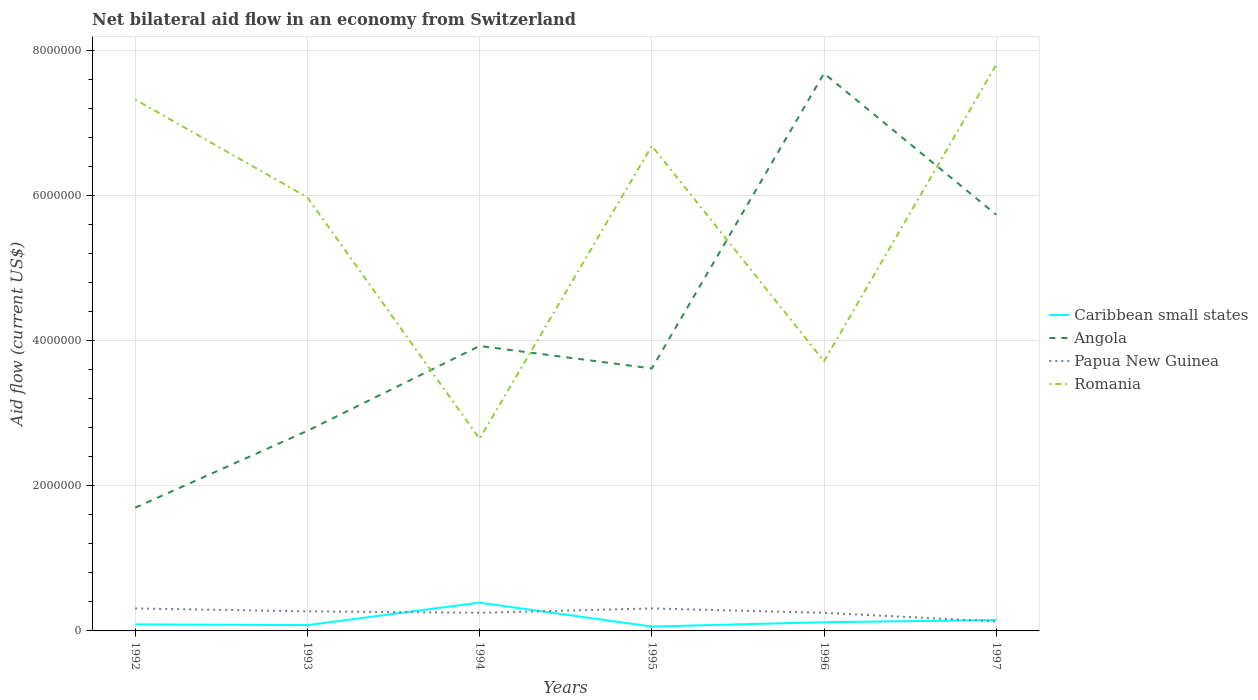How many different coloured lines are there?
Provide a succinct answer. 4. Does the line corresponding to Romania intersect with the line corresponding to Angola?
Offer a very short reply. Yes. Is the number of lines equal to the number of legend labels?
Your response must be concise. Yes. Across all years, what is the maximum net bilateral aid flow in Romania?
Your response must be concise. 2.65e+06. In which year was the net bilateral aid flow in Papua New Guinea maximum?
Offer a terse response. 1997. What is the difference between the highest and the second highest net bilateral aid flow in Romania?
Keep it short and to the point. 5.16e+06. What is the difference between the highest and the lowest net bilateral aid flow in Caribbean small states?
Offer a terse response. 2. Is the net bilateral aid flow in Caribbean small states strictly greater than the net bilateral aid flow in Papua New Guinea over the years?
Give a very brief answer. No. What is the difference between two consecutive major ticks on the Y-axis?
Provide a succinct answer. 2.00e+06. Are the values on the major ticks of Y-axis written in scientific E-notation?
Keep it short and to the point. No. Where does the legend appear in the graph?
Provide a succinct answer. Center right. How many legend labels are there?
Keep it short and to the point. 4. How are the legend labels stacked?
Make the answer very short. Vertical. What is the title of the graph?
Ensure brevity in your answer.  Net bilateral aid flow in an economy from Switzerland. What is the label or title of the Y-axis?
Give a very brief answer. Aid flow (current US$). What is the Aid flow (current US$) in Angola in 1992?
Your answer should be compact. 1.70e+06. What is the Aid flow (current US$) of Papua New Guinea in 1992?
Give a very brief answer. 3.10e+05. What is the Aid flow (current US$) of Romania in 1992?
Make the answer very short. 7.33e+06. What is the Aid flow (current US$) of Caribbean small states in 1993?
Keep it short and to the point. 8.00e+04. What is the Aid flow (current US$) in Angola in 1993?
Offer a terse response. 2.76e+06. What is the Aid flow (current US$) of Papua New Guinea in 1993?
Give a very brief answer. 2.70e+05. What is the Aid flow (current US$) of Romania in 1993?
Give a very brief answer. 5.98e+06. What is the Aid flow (current US$) in Caribbean small states in 1994?
Offer a very short reply. 3.90e+05. What is the Aid flow (current US$) of Angola in 1994?
Your response must be concise. 3.93e+06. What is the Aid flow (current US$) in Papua New Guinea in 1994?
Your answer should be very brief. 2.50e+05. What is the Aid flow (current US$) in Romania in 1994?
Provide a succinct answer. 2.65e+06. What is the Aid flow (current US$) of Caribbean small states in 1995?
Provide a short and direct response. 6.00e+04. What is the Aid flow (current US$) in Angola in 1995?
Provide a succinct answer. 3.62e+06. What is the Aid flow (current US$) in Romania in 1995?
Your answer should be very brief. 6.69e+06. What is the Aid flow (current US$) of Angola in 1996?
Offer a very short reply. 7.69e+06. What is the Aid flow (current US$) in Papua New Guinea in 1996?
Provide a short and direct response. 2.50e+05. What is the Aid flow (current US$) in Romania in 1996?
Provide a short and direct response. 3.72e+06. What is the Aid flow (current US$) in Angola in 1997?
Your answer should be compact. 5.74e+06. What is the Aid flow (current US$) in Romania in 1997?
Give a very brief answer. 7.81e+06. Across all years, what is the maximum Aid flow (current US$) in Caribbean small states?
Make the answer very short. 3.90e+05. Across all years, what is the maximum Aid flow (current US$) in Angola?
Your response must be concise. 7.69e+06. Across all years, what is the maximum Aid flow (current US$) in Romania?
Offer a terse response. 7.81e+06. Across all years, what is the minimum Aid flow (current US$) in Angola?
Offer a terse response. 1.70e+06. Across all years, what is the minimum Aid flow (current US$) of Papua New Guinea?
Your answer should be very brief. 1.30e+05. Across all years, what is the minimum Aid flow (current US$) in Romania?
Your answer should be very brief. 2.65e+06. What is the total Aid flow (current US$) in Caribbean small states in the graph?
Keep it short and to the point. 8.90e+05. What is the total Aid flow (current US$) of Angola in the graph?
Provide a short and direct response. 2.54e+07. What is the total Aid flow (current US$) of Papua New Guinea in the graph?
Keep it short and to the point. 1.52e+06. What is the total Aid flow (current US$) of Romania in the graph?
Your response must be concise. 3.42e+07. What is the difference between the Aid flow (current US$) in Angola in 1992 and that in 1993?
Provide a short and direct response. -1.06e+06. What is the difference between the Aid flow (current US$) of Papua New Guinea in 1992 and that in 1993?
Provide a succinct answer. 4.00e+04. What is the difference between the Aid flow (current US$) of Romania in 1992 and that in 1993?
Give a very brief answer. 1.35e+06. What is the difference between the Aid flow (current US$) in Caribbean small states in 1992 and that in 1994?
Ensure brevity in your answer.  -3.00e+05. What is the difference between the Aid flow (current US$) in Angola in 1992 and that in 1994?
Your answer should be very brief. -2.23e+06. What is the difference between the Aid flow (current US$) of Papua New Guinea in 1992 and that in 1994?
Provide a succinct answer. 6.00e+04. What is the difference between the Aid flow (current US$) in Romania in 1992 and that in 1994?
Ensure brevity in your answer.  4.68e+06. What is the difference between the Aid flow (current US$) in Angola in 1992 and that in 1995?
Offer a very short reply. -1.92e+06. What is the difference between the Aid flow (current US$) of Papua New Guinea in 1992 and that in 1995?
Keep it short and to the point. 0. What is the difference between the Aid flow (current US$) in Romania in 1992 and that in 1995?
Ensure brevity in your answer.  6.40e+05. What is the difference between the Aid flow (current US$) in Angola in 1992 and that in 1996?
Offer a terse response. -5.99e+06. What is the difference between the Aid flow (current US$) in Romania in 1992 and that in 1996?
Give a very brief answer. 3.61e+06. What is the difference between the Aid flow (current US$) of Caribbean small states in 1992 and that in 1997?
Ensure brevity in your answer.  -6.00e+04. What is the difference between the Aid flow (current US$) in Angola in 1992 and that in 1997?
Provide a short and direct response. -4.04e+06. What is the difference between the Aid flow (current US$) of Papua New Guinea in 1992 and that in 1997?
Offer a very short reply. 1.80e+05. What is the difference between the Aid flow (current US$) of Romania in 1992 and that in 1997?
Your response must be concise. -4.80e+05. What is the difference between the Aid flow (current US$) in Caribbean small states in 1993 and that in 1994?
Offer a very short reply. -3.10e+05. What is the difference between the Aid flow (current US$) of Angola in 1993 and that in 1994?
Make the answer very short. -1.17e+06. What is the difference between the Aid flow (current US$) of Papua New Guinea in 1993 and that in 1994?
Offer a terse response. 2.00e+04. What is the difference between the Aid flow (current US$) in Romania in 1993 and that in 1994?
Your answer should be compact. 3.33e+06. What is the difference between the Aid flow (current US$) of Caribbean small states in 1993 and that in 1995?
Ensure brevity in your answer.  2.00e+04. What is the difference between the Aid flow (current US$) of Angola in 1993 and that in 1995?
Make the answer very short. -8.60e+05. What is the difference between the Aid flow (current US$) in Romania in 1993 and that in 1995?
Give a very brief answer. -7.10e+05. What is the difference between the Aid flow (current US$) in Angola in 1993 and that in 1996?
Your answer should be very brief. -4.93e+06. What is the difference between the Aid flow (current US$) of Romania in 1993 and that in 1996?
Provide a short and direct response. 2.26e+06. What is the difference between the Aid flow (current US$) in Caribbean small states in 1993 and that in 1997?
Offer a very short reply. -7.00e+04. What is the difference between the Aid flow (current US$) in Angola in 1993 and that in 1997?
Your response must be concise. -2.98e+06. What is the difference between the Aid flow (current US$) of Romania in 1993 and that in 1997?
Ensure brevity in your answer.  -1.83e+06. What is the difference between the Aid flow (current US$) of Caribbean small states in 1994 and that in 1995?
Give a very brief answer. 3.30e+05. What is the difference between the Aid flow (current US$) of Papua New Guinea in 1994 and that in 1995?
Provide a succinct answer. -6.00e+04. What is the difference between the Aid flow (current US$) in Romania in 1994 and that in 1995?
Provide a succinct answer. -4.04e+06. What is the difference between the Aid flow (current US$) in Caribbean small states in 1994 and that in 1996?
Your response must be concise. 2.70e+05. What is the difference between the Aid flow (current US$) in Angola in 1994 and that in 1996?
Make the answer very short. -3.76e+06. What is the difference between the Aid flow (current US$) in Papua New Guinea in 1994 and that in 1996?
Ensure brevity in your answer.  0. What is the difference between the Aid flow (current US$) of Romania in 1994 and that in 1996?
Your answer should be very brief. -1.07e+06. What is the difference between the Aid flow (current US$) in Angola in 1994 and that in 1997?
Offer a very short reply. -1.81e+06. What is the difference between the Aid flow (current US$) in Romania in 1994 and that in 1997?
Give a very brief answer. -5.16e+06. What is the difference between the Aid flow (current US$) in Angola in 1995 and that in 1996?
Your answer should be very brief. -4.07e+06. What is the difference between the Aid flow (current US$) of Papua New Guinea in 1995 and that in 1996?
Ensure brevity in your answer.  6.00e+04. What is the difference between the Aid flow (current US$) in Romania in 1995 and that in 1996?
Give a very brief answer. 2.97e+06. What is the difference between the Aid flow (current US$) in Caribbean small states in 1995 and that in 1997?
Keep it short and to the point. -9.00e+04. What is the difference between the Aid flow (current US$) of Angola in 1995 and that in 1997?
Your answer should be compact. -2.12e+06. What is the difference between the Aid flow (current US$) of Papua New Guinea in 1995 and that in 1997?
Offer a very short reply. 1.80e+05. What is the difference between the Aid flow (current US$) in Romania in 1995 and that in 1997?
Provide a short and direct response. -1.12e+06. What is the difference between the Aid flow (current US$) in Angola in 1996 and that in 1997?
Provide a succinct answer. 1.95e+06. What is the difference between the Aid flow (current US$) in Romania in 1996 and that in 1997?
Keep it short and to the point. -4.09e+06. What is the difference between the Aid flow (current US$) of Caribbean small states in 1992 and the Aid flow (current US$) of Angola in 1993?
Your answer should be compact. -2.67e+06. What is the difference between the Aid flow (current US$) in Caribbean small states in 1992 and the Aid flow (current US$) in Romania in 1993?
Keep it short and to the point. -5.89e+06. What is the difference between the Aid flow (current US$) of Angola in 1992 and the Aid flow (current US$) of Papua New Guinea in 1993?
Your response must be concise. 1.43e+06. What is the difference between the Aid flow (current US$) in Angola in 1992 and the Aid flow (current US$) in Romania in 1993?
Your response must be concise. -4.28e+06. What is the difference between the Aid flow (current US$) of Papua New Guinea in 1992 and the Aid flow (current US$) of Romania in 1993?
Offer a terse response. -5.67e+06. What is the difference between the Aid flow (current US$) in Caribbean small states in 1992 and the Aid flow (current US$) in Angola in 1994?
Make the answer very short. -3.84e+06. What is the difference between the Aid flow (current US$) of Caribbean small states in 1992 and the Aid flow (current US$) of Romania in 1994?
Your answer should be very brief. -2.56e+06. What is the difference between the Aid flow (current US$) of Angola in 1992 and the Aid flow (current US$) of Papua New Guinea in 1994?
Give a very brief answer. 1.45e+06. What is the difference between the Aid flow (current US$) in Angola in 1992 and the Aid flow (current US$) in Romania in 1994?
Your answer should be very brief. -9.50e+05. What is the difference between the Aid flow (current US$) of Papua New Guinea in 1992 and the Aid flow (current US$) of Romania in 1994?
Your response must be concise. -2.34e+06. What is the difference between the Aid flow (current US$) in Caribbean small states in 1992 and the Aid flow (current US$) in Angola in 1995?
Your response must be concise. -3.53e+06. What is the difference between the Aid flow (current US$) of Caribbean small states in 1992 and the Aid flow (current US$) of Papua New Guinea in 1995?
Offer a very short reply. -2.20e+05. What is the difference between the Aid flow (current US$) in Caribbean small states in 1992 and the Aid flow (current US$) in Romania in 1995?
Provide a short and direct response. -6.60e+06. What is the difference between the Aid flow (current US$) of Angola in 1992 and the Aid flow (current US$) of Papua New Guinea in 1995?
Offer a very short reply. 1.39e+06. What is the difference between the Aid flow (current US$) of Angola in 1992 and the Aid flow (current US$) of Romania in 1995?
Ensure brevity in your answer.  -4.99e+06. What is the difference between the Aid flow (current US$) of Papua New Guinea in 1992 and the Aid flow (current US$) of Romania in 1995?
Offer a very short reply. -6.38e+06. What is the difference between the Aid flow (current US$) of Caribbean small states in 1992 and the Aid flow (current US$) of Angola in 1996?
Keep it short and to the point. -7.60e+06. What is the difference between the Aid flow (current US$) in Caribbean small states in 1992 and the Aid flow (current US$) in Papua New Guinea in 1996?
Offer a terse response. -1.60e+05. What is the difference between the Aid flow (current US$) of Caribbean small states in 1992 and the Aid flow (current US$) of Romania in 1996?
Your response must be concise. -3.63e+06. What is the difference between the Aid flow (current US$) of Angola in 1992 and the Aid flow (current US$) of Papua New Guinea in 1996?
Give a very brief answer. 1.45e+06. What is the difference between the Aid flow (current US$) in Angola in 1992 and the Aid flow (current US$) in Romania in 1996?
Your response must be concise. -2.02e+06. What is the difference between the Aid flow (current US$) in Papua New Guinea in 1992 and the Aid flow (current US$) in Romania in 1996?
Keep it short and to the point. -3.41e+06. What is the difference between the Aid flow (current US$) of Caribbean small states in 1992 and the Aid flow (current US$) of Angola in 1997?
Your response must be concise. -5.65e+06. What is the difference between the Aid flow (current US$) of Caribbean small states in 1992 and the Aid flow (current US$) of Romania in 1997?
Give a very brief answer. -7.72e+06. What is the difference between the Aid flow (current US$) in Angola in 1992 and the Aid flow (current US$) in Papua New Guinea in 1997?
Offer a very short reply. 1.57e+06. What is the difference between the Aid flow (current US$) of Angola in 1992 and the Aid flow (current US$) of Romania in 1997?
Give a very brief answer. -6.11e+06. What is the difference between the Aid flow (current US$) in Papua New Guinea in 1992 and the Aid flow (current US$) in Romania in 1997?
Provide a short and direct response. -7.50e+06. What is the difference between the Aid flow (current US$) of Caribbean small states in 1993 and the Aid flow (current US$) of Angola in 1994?
Your answer should be compact. -3.85e+06. What is the difference between the Aid flow (current US$) of Caribbean small states in 1993 and the Aid flow (current US$) of Papua New Guinea in 1994?
Provide a succinct answer. -1.70e+05. What is the difference between the Aid flow (current US$) in Caribbean small states in 1993 and the Aid flow (current US$) in Romania in 1994?
Your response must be concise. -2.57e+06. What is the difference between the Aid flow (current US$) of Angola in 1993 and the Aid flow (current US$) of Papua New Guinea in 1994?
Your answer should be very brief. 2.51e+06. What is the difference between the Aid flow (current US$) in Papua New Guinea in 1993 and the Aid flow (current US$) in Romania in 1994?
Your answer should be compact. -2.38e+06. What is the difference between the Aid flow (current US$) in Caribbean small states in 1993 and the Aid flow (current US$) in Angola in 1995?
Provide a succinct answer. -3.54e+06. What is the difference between the Aid flow (current US$) of Caribbean small states in 1993 and the Aid flow (current US$) of Romania in 1995?
Provide a short and direct response. -6.61e+06. What is the difference between the Aid flow (current US$) of Angola in 1993 and the Aid flow (current US$) of Papua New Guinea in 1995?
Offer a very short reply. 2.45e+06. What is the difference between the Aid flow (current US$) in Angola in 1993 and the Aid flow (current US$) in Romania in 1995?
Your answer should be compact. -3.93e+06. What is the difference between the Aid flow (current US$) in Papua New Guinea in 1993 and the Aid flow (current US$) in Romania in 1995?
Your answer should be very brief. -6.42e+06. What is the difference between the Aid flow (current US$) of Caribbean small states in 1993 and the Aid flow (current US$) of Angola in 1996?
Your response must be concise. -7.61e+06. What is the difference between the Aid flow (current US$) of Caribbean small states in 1993 and the Aid flow (current US$) of Romania in 1996?
Provide a short and direct response. -3.64e+06. What is the difference between the Aid flow (current US$) of Angola in 1993 and the Aid flow (current US$) of Papua New Guinea in 1996?
Keep it short and to the point. 2.51e+06. What is the difference between the Aid flow (current US$) in Angola in 1993 and the Aid flow (current US$) in Romania in 1996?
Make the answer very short. -9.60e+05. What is the difference between the Aid flow (current US$) of Papua New Guinea in 1993 and the Aid flow (current US$) of Romania in 1996?
Ensure brevity in your answer.  -3.45e+06. What is the difference between the Aid flow (current US$) of Caribbean small states in 1993 and the Aid flow (current US$) of Angola in 1997?
Provide a short and direct response. -5.66e+06. What is the difference between the Aid flow (current US$) of Caribbean small states in 1993 and the Aid flow (current US$) of Papua New Guinea in 1997?
Your answer should be very brief. -5.00e+04. What is the difference between the Aid flow (current US$) in Caribbean small states in 1993 and the Aid flow (current US$) in Romania in 1997?
Offer a very short reply. -7.73e+06. What is the difference between the Aid flow (current US$) in Angola in 1993 and the Aid flow (current US$) in Papua New Guinea in 1997?
Offer a terse response. 2.63e+06. What is the difference between the Aid flow (current US$) of Angola in 1993 and the Aid flow (current US$) of Romania in 1997?
Give a very brief answer. -5.05e+06. What is the difference between the Aid flow (current US$) of Papua New Guinea in 1993 and the Aid flow (current US$) of Romania in 1997?
Offer a very short reply. -7.54e+06. What is the difference between the Aid flow (current US$) in Caribbean small states in 1994 and the Aid flow (current US$) in Angola in 1995?
Make the answer very short. -3.23e+06. What is the difference between the Aid flow (current US$) of Caribbean small states in 1994 and the Aid flow (current US$) of Romania in 1995?
Provide a short and direct response. -6.30e+06. What is the difference between the Aid flow (current US$) in Angola in 1994 and the Aid flow (current US$) in Papua New Guinea in 1995?
Your answer should be very brief. 3.62e+06. What is the difference between the Aid flow (current US$) in Angola in 1994 and the Aid flow (current US$) in Romania in 1995?
Offer a terse response. -2.76e+06. What is the difference between the Aid flow (current US$) of Papua New Guinea in 1994 and the Aid flow (current US$) of Romania in 1995?
Provide a succinct answer. -6.44e+06. What is the difference between the Aid flow (current US$) of Caribbean small states in 1994 and the Aid flow (current US$) of Angola in 1996?
Offer a very short reply. -7.30e+06. What is the difference between the Aid flow (current US$) of Caribbean small states in 1994 and the Aid flow (current US$) of Romania in 1996?
Make the answer very short. -3.33e+06. What is the difference between the Aid flow (current US$) in Angola in 1994 and the Aid flow (current US$) in Papua New Guinea in 1996?
Give a very brief answer. 3.68e+06. What is the difference between the Aid flow (current US$) of Papua New Guinea in 1994 and the Aid flow (current US$) of Romania in 1996?
Provide a succinct answer. -3.47e+06. What is the difference between the Aid flow (current US$) in Caribbean small states in 1994 and the Aid flow (current US$) in Angola in 1997?
Offer a very short reply. -5.35e+06. What is the difference between the Aid flow (current US$) in Caribbean small states in 1994 and the Aid flow (current US$) in Papua New Guinea in 1997?
Your response must be concise. 2.60e+05. What is the difference between the Aid flow (current US$) in Caribbean small states in 1994 and the Aid flow (current US$) in Romania in 1997?
Your answer should be very brief. -7.42e+06. What is the difference between the Aid flow (current US$) of Angola in 1994 and the Aid flow (current US$) of Papua New Guinea in 1997?
Ensure brevity in your answer.  3.80e+06. What is the difference between the Aid flow (current US$) in Angola in 1994 and the Aid flow (current US$) in Romania in 1997?
Offer a terse response. -3.88e+06. What is the difference between the Aid flow (current US$) of Papua New Guinea in 1994 and the Aid flow (current US$) of Romania in 1997?
Offer a very short reply. -7.56e+06. What is the difference between the Aid flow (current US$) in Caribbean small states in 1995 and the Aid flow (current US$) in Angola in 1996?
Make the answer very short. -7.63e+06. What is the difference between the Aid flow (current US$) in Caribbean small states in 1995 and the Aid flow (current US$) in Papua New Guinea in 1996?
Ensure brevity in your answer.  -1.90e+05. What is the difference between the Aid flow (current US$) in Caribbean small states in 1995 and the Aid flow (current US$) in Romania in 1996?
Give a very brief answer. -3.66e+06. What is the difference between the Aid flow (current US$) in Angola in 1995 and the Aid flow (current US$) in Papua New Guinea in 1996?
Your response must be concise. 3.37e+06. What is the difference between the Aid flow (current US$) of Papua New Guinea in 1995 and the Aid flow (current US$) of Romania in 1996?
Offer a very short reply. -3.41e+06. What is the difference between the Aid flow (current US$) of Caribbean small states in 1995 and the Aid flow (current US$) of Angola in 1997?
Provide a succinct answer. -5.68e+06. What is the difference between the Aid flow (current US$) in Caribbean small states in 1995 and the Aid flow (current US$) in Papua New Guinea in 1997?
Make the answer very short. -7.00e+04. What is the difference between the Aid flow (current US$) in Caribbean small states in 1995 and the Aid flow (current US$) in Romania in 1997?
Provide a succinct answer. -7.75e+06. What is the difference between the Aid flow (current US$) in Angola in 1995 and the Aid flow (current US$) in Papua New Guinea in 1997?
Keep it short and to the point. 3.49e+06. What is the difference between the Aid flow (current US$) in Angola in 1995 and the Aid flow (current US$) in Romania in 1997?
Make the answer very short. -4.19e+06. What is the difference between the Aid flow (current US$) in Papua New Guinea in 1995 and the Aid flow (current US$) in Romania in 1997?
Keep it short and to the point. -7.50e+06. What is the difference between the Aid flow (current US$) in Caribbean small states in 1996 and the Aid flow (current US$) in Angola in 1997?
Provide a short and direct response. -5.62e+06. What is the difference between the Aid flow (current US$) in Caribbean small states in 1996 and the Aid flow (current US$) in Papua New Guinea in 1997?
Your response must be concise. -10000. What is the difference between the Aid flow (current US$) in Caribbean small states in 1996 and the Aid flow (current US$) in Romania in 1997?
Provide a succinct answer. -7.69e+06. What is the difference between the Aid flow (current US$) of Angola in 1996 and the Aid flow (current US$) of Papua New Guinea in 1997?
Give a very brief answer. 7.56e+06. What is the difference between the Aid flow (current US$) of Papua New Guinea in 1996 and the Aid flow (current US$) of Romania in 1997?
Offer a very short reply. -7.56e+06. What is the average Aid flow (current US$) of Caribbean small states per year?
Your answer should be very brief. 1.48e+05. What is the average Aid flow (current US$) in Angola per year?
Your answer should be very brief. 4.24e+06. What is the average Aid flow (current US$) of Papua New Guinea per year?
Offer a terse response. 2.53e+05. What is the average Aid flow (current US$) in Romania per year?
Keep it short and to the point. 5.70e+06. In the year 1992, what is the difference between the Aid flow (current US$) of Caribbean small states and Aid flow (current US$) of Angola?
Provide a succinct answer. -1.61e+06. In the year 1992, what is the difference between the Aid flow (current US$) of Caribbean small states and Aid flow (current US$) of Papua New Guinea?
Your answer should be compact. -2.20e+05. In the year 1992, what is the difference between the Aid flow (current US$) of Caribbean small states and Aid flow (current US$) of Romania?
Provide a short and direct response. -7.24e+06. In the year 1992, what is the difference between the Aid flow (current US$) of Angola and Aid flow (current US$) of Papua New Guinea?
Give a very brief answer. 1.39e+06. In the year 1992, what is the difference between the Aid flow (current US$) in Angola and Aid flow (current US$) in Romania?
Provide a short and direct response. -5.63e+06. In the year 1992, what is the difference between the Aid flow (current US$) in Papua New Guinea and Aid flow (current US$) in Romania?
Provide a short and direct response. -7.02e+06. In the year 1993, what is the difference between the Aid flow (current US$) of Caribbean small states and Aid flow (current US$) of Angola?
Provide a short and direct response. -2.68e+06. In the year 1993, what is the difference between the Aid flow (current US$) of Caribbean small states and Aid flow (current US$) of Romania?
Your answer should be very brief. -5.90e+06. In the year 1993, what is the difference between the Aid flow (current US$) in Angola and Aid flow (current US$) in Papua New Guinea?
Make the answer very short. 2.49e+06. In the year 1993, what is the difference between the Aid flow (current US$) of Angola and Aid flow (current US$) of Romania?
Your answer should be compact. -3.22e+06. In the year 1993, what is the difference between the Aid flow (current US$) of Papua New Guinea and Aid flow (current US$) of Romania?
Your response must be concise. -5.71e+06. In the year 1994, what is the difference between the Aid flow (current US$) in Caribbean small states and Aid flow (current US$) in Angola?
Your answer should be compact. -3.54e+06. In the year 1994, what is the difference between the Aid flow (current US$) of Caribbean small states and Aid flow (current US$) of Papua New Guinea?
Your answer should be compact. 1.40e+05. In the year 1994, what is the difference between the Aid flow (current US$) in Caribbean small states and Aid flow (current US$) in Romania?
Offer a terse response. -2.26e+06. In the year 1994, what is the difference between the Aid flow (current US$) of Angola and Aid flow (current US$) of Papua New Guinea?
Ensure brevity in your answer.  3.68e+06. In the year 1994, what is the difference between the Aid flow (current US$) of Angola and Aid flow (current US$) of Romania?
Provide a short and direct response. 1.28e+06. In the year 1994, what is the difference between the Aid flow (current US$) of Papua New Guinea and Aid flow (current US$) of Romania?
Offer a very short reply. -2.40e+06. In the year 1995, what is the difference between the Aid flow (current US$) of Caribbean small states and Aid flow (current US$) of Angola?
Your answer should be very brief. -3.56e+06. In the year 1995, what is the difference between the Aid flow (current US$) in Caribbean small states and Aid flow (current US$) in Papua New Guinea?
Give a very brief answer. -2.50e+05. In the year 1995, what is the difference between the Aid flow (current US$) in Caribbean small states and Aid flow (current US$) in Romania?
Your answer should be very brief. -6.63e+06. In the year 1995, what is the difference between the Aid flow (current US$) of Angola and Aid flow (current US$) of Papua New Guinea?
Offer a very short reply. 3.31e+06. In the year 1995, what is the difference between the Aid flow (current US$) of Angola and Aid flow (current US$) of Romania?
Your answer should be compact. -3.07e+06. In the year 1995, what is the difference between the Aid flow (current US$) of Papua New Guinea and Aid flow (current US$) of Romania?
Your answer should be compact. -6.38e+06. In the year 1996, what is the difference between the Aid flow (current US$) of Caribbean small states and Aid flow (current US$) of Angola?
Provide a succinct answer. -7.57e+06. In the year 1996, what is the difference between the Aid flow (current US$) in Caribbean small states and Aid flow (current US$) in Romania?
Your answer should be very brief. -3.60e+06. In the year 1996, what is the difference between the Aid flow (current US$) of Angola and Aid flow (current US$) of Papua New Guinea?
Make the answer very short. 7.44e+06. In the year 1996, what is the difference between the Aid flow (current US$) in Angola and Aid flow (current US$) in Romania?
Provide a succinct answer. 3.97e+06. In the year 1996, what is the difference between the Aid flow (current US$) of Papua New Guinea and Aid flow (current US$) of Romania?
Ensure brevity in your answer.  -3.47e+06. In the year 1997, what is the difference between the Aid flow (current US$) of Caribbean small states and Aid flow (current US$) of Angola?
Offer a very short reply. -5.59e+06. In the year 1997, what is the difference between the Aid flow (current US$) of Caribbean small states and Aid flow (current US$) of Romania?
Give a very brief answer. -7.66e+06. In the year 1997, what is the difference between the Aid flow (current US$) of Angola and Aid flow (current US$) of Papua New Guinea?
Ensure brevity in your answer.  5.61e+06. In the year 1997, what is the difference between the Aid flow (current US$) of Angola and Aid flow (current US$) of Romania?
Make the answer very short. -2.07e+06. In the year 1997, what is the difference between the Aid flow (current US$) of Papua New Guinea and Aid flow (current US$) of Romania?
Your answer should be very brief. -7.68e+06. What is the ratio of the Aid flow (current US$) in Caribbean small states in 1992 to that in 1993?
Provide a succinct answer. 1.12. What is the ratio of the Aid flow (current US$) in Angola in 1992 to that in 1993?
Make the answer very short. 0.62. What is the ratio of the Aid flow (current US$) in Papua New Guinea in 1992 to that in 1993?
Offer a very short reply. 1.15. What is the ratio of the Aid flow (current US$) in Romania in 1992 to that in 1993?
Offer a very short reply. 1.23. What is the ratio of the Aid flow (current US$) of Caribbean small states in 1992 to that in 1994?
Your answer should be very brief. 0.23. What is the ratio of the Aid flow (current US$) of Angola in 1992 to that in 1994?
Offer a very short reply. 0.43. What is the ratio of the Aid flow (current US$) of Papua New Guinea in 1992 to that in 1994?
Give a very brief answer. 1.24. What is the ratio of the Aid flow (current US$) in Romania in 1992 to that in 1994?
Offer a terse response. 2.77. What is the ratio of the Aid flow (current US$) of Angola in 1992 to that in 1995?
Offer a very short reply. 0.47. What is the ratio of the Aid flow (current US$) of Romania in 1992 to that in 1995?
Keep it short and to the point. 1.1. What is the ratio of the Aid flow (current US$) in Angola in 1992 to that in 1996?
Give a very brief answer. 0.22. What is the ratio of the Aid flow (current US$) of Papua New Guinea in 1992 to that in 1996?
Offer a terse response. 1.24. What is the ratio of the Aid flow (current US$) of Romania in 1992 to that in 1996?
Offer a very short reply. 1.97. What is the ratio of the Aid flow (current US$) in Caribbean small states in 1992 to that in 1997?
Offer a terse response. 0.6. What is the ratio of the Aid flow (current US$) in Angola in 1992 to that in 1997?
Your response must be concise. 0.3. What is the ratio of the Aid flow (current US$) in Papua New Guinea in 1992 to that in 1997?
Provide a succinct answer. 2.38. What is the ratio of the Aid flow (current US$) in Romania in 1992 to that in 1997?
Your response must be concise. 0.94. What is the ratio of the Aid flow (current US$) of Caribbean small states in 1993 to that in 1994?
Offer a terse response. 0.21. What is the ratio of the Aid flow (current US$) of Angola in 1993 to that in 1994?
Offer a very short reply. 0.7. What is the ratio of the Aid flow (current US$) in Papua New Guinea in 1993 to that in 1994?
Keep it short and to the point. 1.08. What is the ratio of the Aid flow (current US$) in Romania in 1993 to that in 1994?
Your answer should be compact. 2.26. What is the ratio of the Aid flow (current US$) in Caribbean small states in 1993 to that in 1995?
Provide a short and direct response. 1.33. What is the ratio of the Aid flow (current US$) in Angola in 1993 to that in 1995?
Your response must be concise. 0.76. What is the ratio of the Aid flow (current US$) of Papua New Guinea in 1993 to that in 1995?
Offer a terse response. 0.87. What is the ratio of the Aid flow (current US$) of Romania in 1993 to that in 1995?
Provide a succinct answer. 0.89. What is the ratio of the Aid flow (current US$) of Angola in 1993 to that in 1996?
Your response must be concise. 0.36. What is the ratio of the Aid flow (current US$) of Papua New Guinea in 1993 to that in 1996?
Offer a terse response. 1.08. What is the ratio of the Aid flow (current US$) of Romania in 1993 to that in 1996?
Make the answer very short. 1.61. What is the ratio of the Aid flow (current US$) of Caribbean small states in 1993 to that in 1997?
Your answer should be very brief. 0.53. What is the ratio of the Aid flow (current US$) of Angola in 1993 to that in 1997?
Offer a very short reply. 0.48. What is the ratio of the Aid flow (current US$) in Papua New Guinea in 1993 to that in 1997?
Your answer should be compact. 2.08. What is the ratio of the Aid flow (current US$) of Romania in 1993 to that in 1997?
Provide a short and direct response. 0.77. What is the ratio of the Aid flow (current US$) of Angola in 1994 to that in 1995?
Make the answer very short. 1.09. What is the ratio of the Aid flow (current US$) of Papua New Guinea in 1994 to that in 1995?
Your answer should be compact. 0.81. What is the ratio of the Aid flow (current US$) of Romania in 1994 to that in 1995?
Make the answer very short. 0.4. What is the ratio of the Aid flow (current US$) in Angola in 1994 to that in 1996?
Your response must be concise. 0.51. What is the ratio of the Aid flow (current US$) of Romania in 1994 to that in 1996?
Your answer should be very brief. 0.71. What is the ratio of the Aid flow (current US$) in Angola in 1994 to that in 1997?
Make the answer very short. 0.68. What is the ratio of the Aid flow (current US$) of Papua New Guinea in 1994 to that in 1997?
Your response must be concise. 1.92. What is the ratio of the Aid flow (current US$) of Romania in 1994 to that in 1997?
Your answer should be very brief. 0.34. What is the ratio of the Aid flow (current US$) in Caribbean small states in 1995 to that in 1996?
Keep it short and to the point. 0.5. What is the ratio of the Aid flow (current US$) in Angola in 1995 to that in 1996?
Ensure brevity in your answer.  0.47. What is the ratio of the Aid flow (current US$) of Papua New Guinea in 1995 to that in 1996?
Keep it short and to the point. 1.24. What is the ratio of the Aid flow (current US$) of Romania in 1995 to that in 1996?
Your answer should be very brief. 1.8. What is the ratio of the Aid flow (current US$) in Caribbean small states in 1995 to that in 1997?
Offer a terse response. 0.4. What is the ratio of the Aid flow (current US$) in Angola in 1995 to that in 1997?
Give a very brief answer. 0.63. What is the ratio of the Aid flow (current US$) in Papua New Guinea in 1995 to that in 1997?
Give a very brief answer. 2.38. What is the ratio of the Aid flow (current US$) of Romania in 1995 to that in 1997?
Give a very brief answer. 0.86. What is the ratio of the Aid flow (current US$) in Angola in 1996 to that in 1997?
Make the answer very short. 1.34. What is the ratio of the Aid flow (current US$) in Papua New Guinea in 1996 to that in 1997?
Offer a very short reply. 1.92. What is the ratio of the Aid flow (current US$) in Romania in 1996 to that in 1997?
Offer a terse response. 0.48. What is the difference between the highest and the second highest Aid flow (current US$) of Angola?
Provide a succinct answer. 1.95e+06. What is the difference between the highest and the second highest Aid flow (current US$) in Papua New Guinea?
Provide a short and direct response. 0. What is the difference between the highest and the second highest Aid flow (current US$) in Romania?
Ensure brevity in your answer.  4.80e+05. What is the difference between the highest and the lowest Aid flow (current US$) of Caribbean small states?
Your response must be concise. 3.30e+05. What is the difference between the highest and the lowest Aid flow (current US$) in Angola?
Make the answer very short. 5.99e+06. What is the difference between the highest and the lowest Aid flow (current US$) in Papua New Guinea?
Your answer should be compact. 1.80e+05. What is the difference between the highest and the lowest Aid flow (current US$) in Romania?
Offer a very short reply. 5.16e+06. 